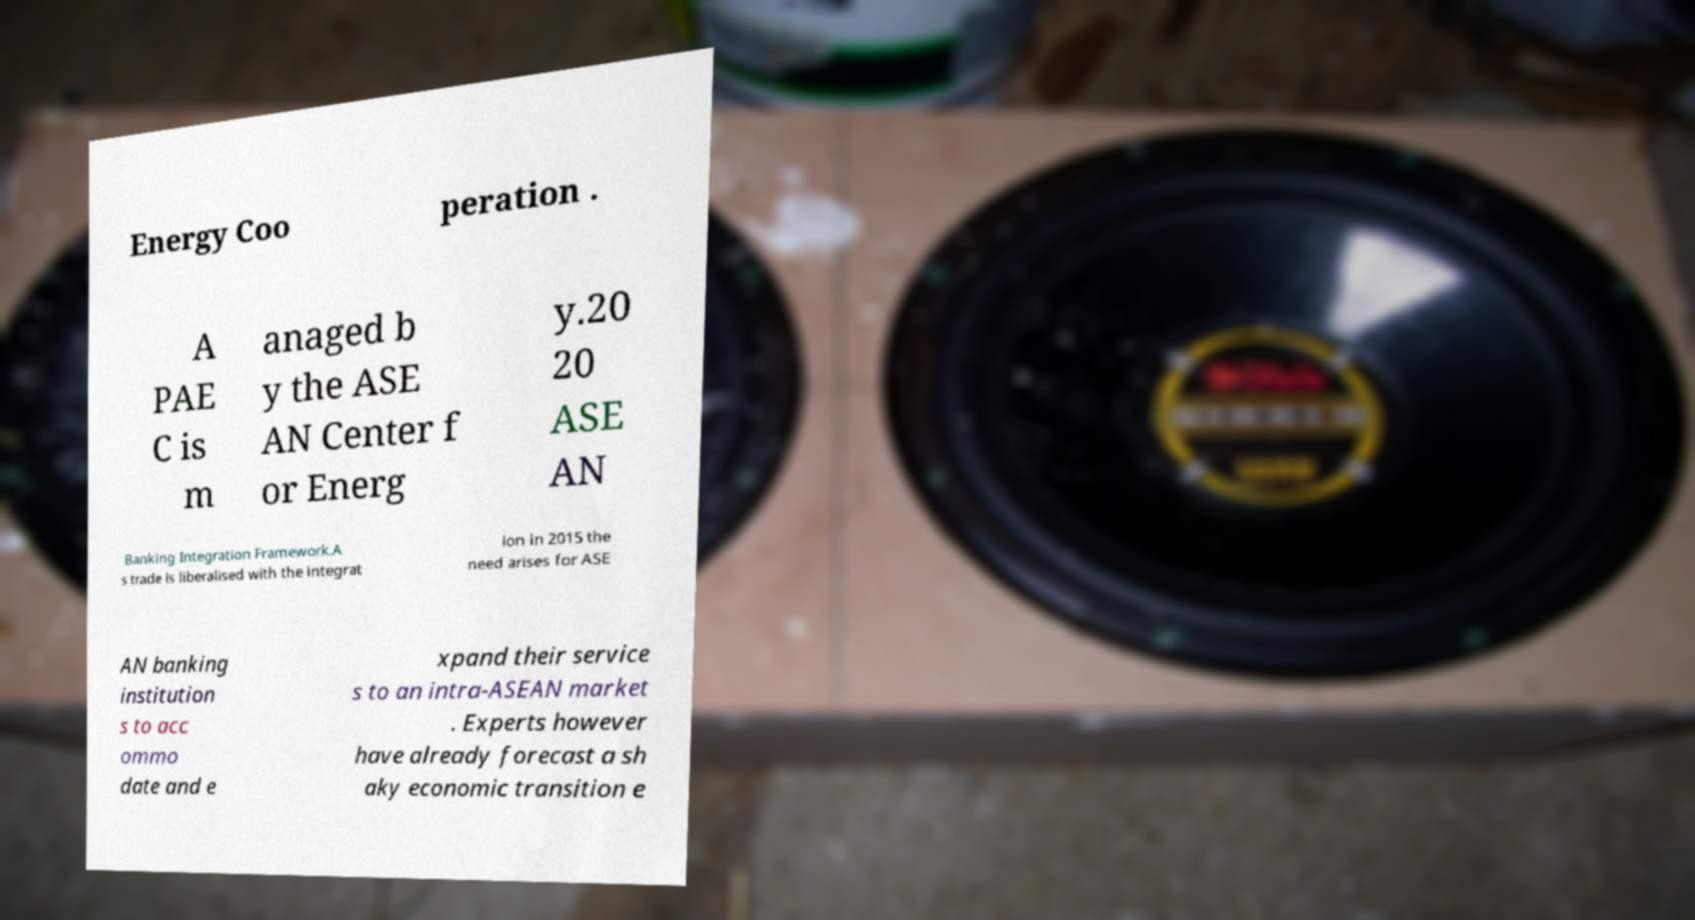Can you read and provide the text displayed in the image?This photo seems to have some interesting text. Can you extract and type it out for me? Energy Coo peration . A PAE C is m anaged b y the ASE AN Center f or Energ y.20 20 ASE AN Banking Integration Framework.A s trade is liberalised with the integrat ion in 2015 the need arises for ASE AN banking institution s to acc ommo date and e xpand their service s to an intra-ASEAN market . Experts however have already forecast a sh aky economic transition e 